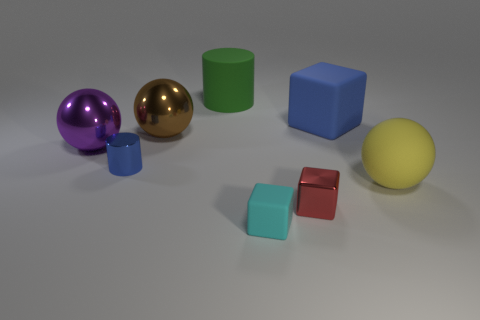How many objects in the image are spherical in shape? In the image, there are two spherical objects: one is a purple sphere, and the other is a yellow sphere. 